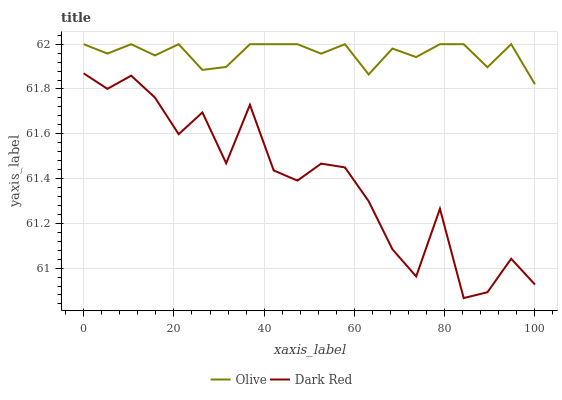Does Dark Red have the minimum area under the curve?
Answer yes or no. Yes. Does Olive have the maximum area under the curve?
Answer yes or no. Yes. Does Dark Red have the maximum area under the curve?
Answer yes or no. No. Is Olive the smoothest?
Answer yes or no. Yes. Is Dark Red the roughest?
Answer yes or no. Yes. Is Dark Red the smoothest?
Answer yes or no. No. Does Dark Red have the lowest value?
Answer yes or no. Yes. Does Olive have the highest value?
Answer yes or no. Yes. Does Dark Red have the highest value?
Answer yes or no. No. Is Dark Red less than Olive?
Answer yes or no. Yes. Is Olive greater than Dark Red?
Answer yes or no. Yes. Does Dark Red intersect Olive?
Answer yes or no. No. 